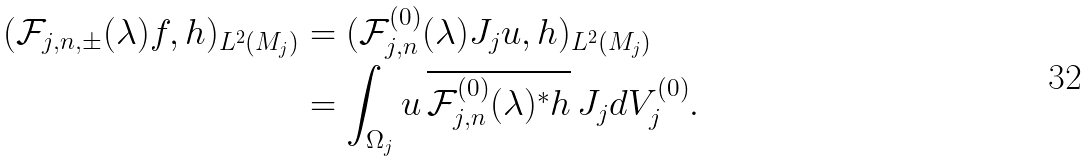<formula> <loc_0><loc_0><loc_500><loc_500>( \mathcal { F } _ { j , n , \pm } ( \lambda ) f , h ) _ { L ^ { 2 } ( M _ { j } ) } & = ( \mathcal { F } _ { j , n } ^ { ( 0 ) } ( \lambda ) J _ { j } u , h ) _ { L ^ { 2 } ( M _ { j } ) } \\ & = \int _ { \Omega _ { j } } u \, \overline { \mathcal { F } _ { j , n } ^ { ( 0 ) } ( \lambda ) ^ { \ast } h } \, J _ { j } d V _ { j } ^ { ( 0 ) } .</formula> 